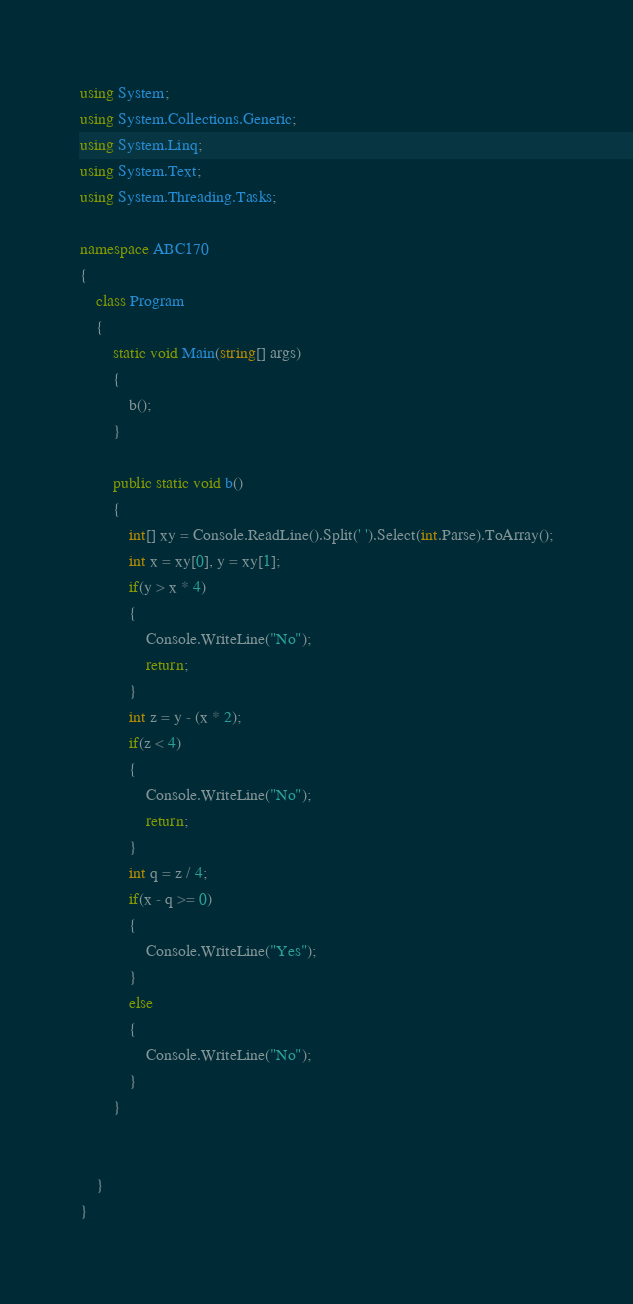Convert code to text. <code><loc_0><loc_0><loc_500><loc_500><_C#_>using System;
using System.Collections.Generic;
using System.Linq;
using System.Text;
using System.Threading.Tasks;

namespace ABC170
{
    class Program
    {
        static void Main(string[] args)
        {
            b();
        }

        public static void b()
        {
            int[] xy = Console.ReadLine().Split(' ').Select(int.Parse).ToArray();
            int x = xy[0], y = xy[1];
            if(y > x * 4)
            {
                Console.WriteLine("No");
                return;
            }
            int z = y - (x * 2);
            if(z < 4)
            {
                Console.WriteLine("No");
                return;
            }
            int q = z / 4;
            if(x - q >= 0)
            {
                Console.WriteLine("Yes");
            }
            else
            {
                Console.WriteLine("No");
            }
        }

        
    }
}
</code> 